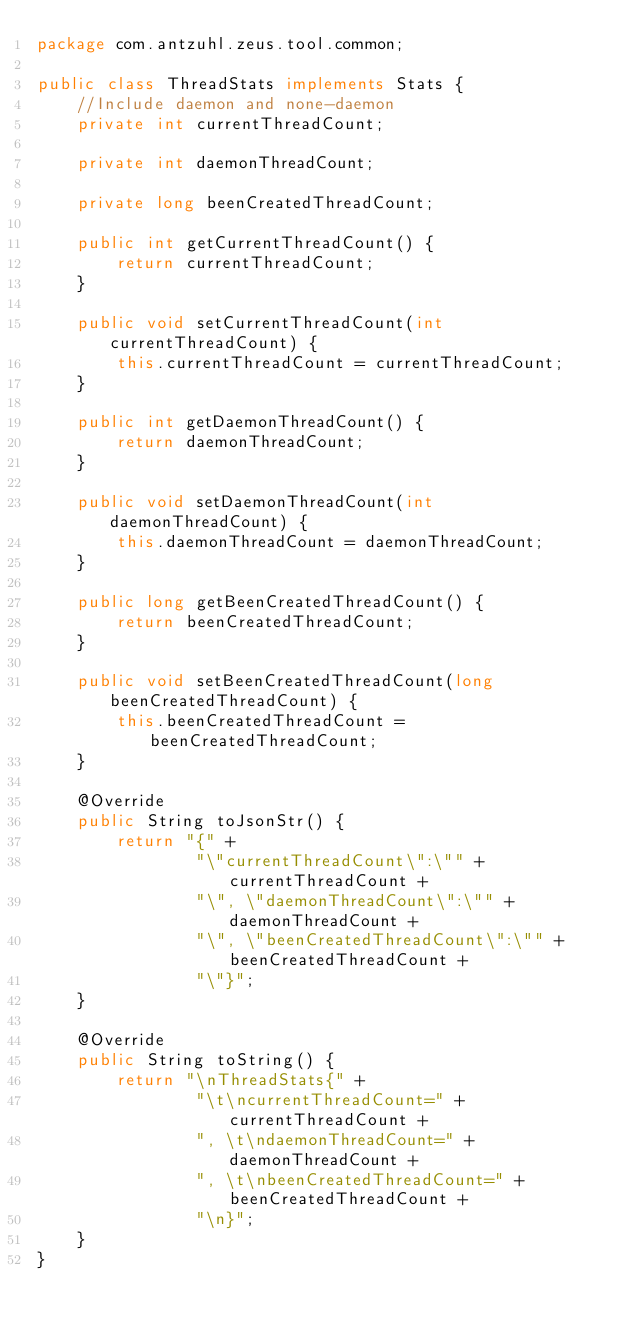<code> <loc_0><loc_0><loc_500><loc_500><_Java_>package com.antzuhl.zeus.tool.common;

public class ThreadStats implements Stats {
    //Include daemon and none-daemon
    private int currentThreadCount;

    private int daemonThreadCount;

    private long beenCreatedThreadCount;

    public int getCurrentThreadCount() {
        return currentThreadCount;
    }

    public void setCurrentThreadCount(int currentThreadCount) {
        this.currentThreadCount = currentThreadCount;
    }

    public int getDaemonThreadCount() {
        return daemonThreadCount;
    }

    public void setDaemonThreadCount(int daemonThreadCount) {
        this.daemonThreadCount = daemonThreadCount;
    }

    public long getBeenCreatedThreadCount() {
        return beenCreatedThreadCount;
    }

    public void setBeenCreatedThreadCount(long beenCreatedThreadCount) {
        this.beenCreatedThreadCount = beenCreatedThreadCount;
    }

    @Override
    public String toJsonStr() {
        return "{" +
                "\"currentThreadCount\":\"" + currentThreadCount +
                "\", \"daemonThreadCount\":\"" + daemonThreadCount +
                "\", \"beenCreatedThreadCount\":\"" + beenCreatedThreadCount +
                "\"}";
    }

    @Override
    public String toString() {
        return "\nThreadStats{" +
                "\t\ncurrentThreadCount=" + currentThreadCount +
                ", \t\ndaemonThreadCount=" + daemonThreadCount +
                ", \t\nbeenCreatedThreadCount=" + beenCreatedThreadCount +
                "\n}";
    }
}
</code> 